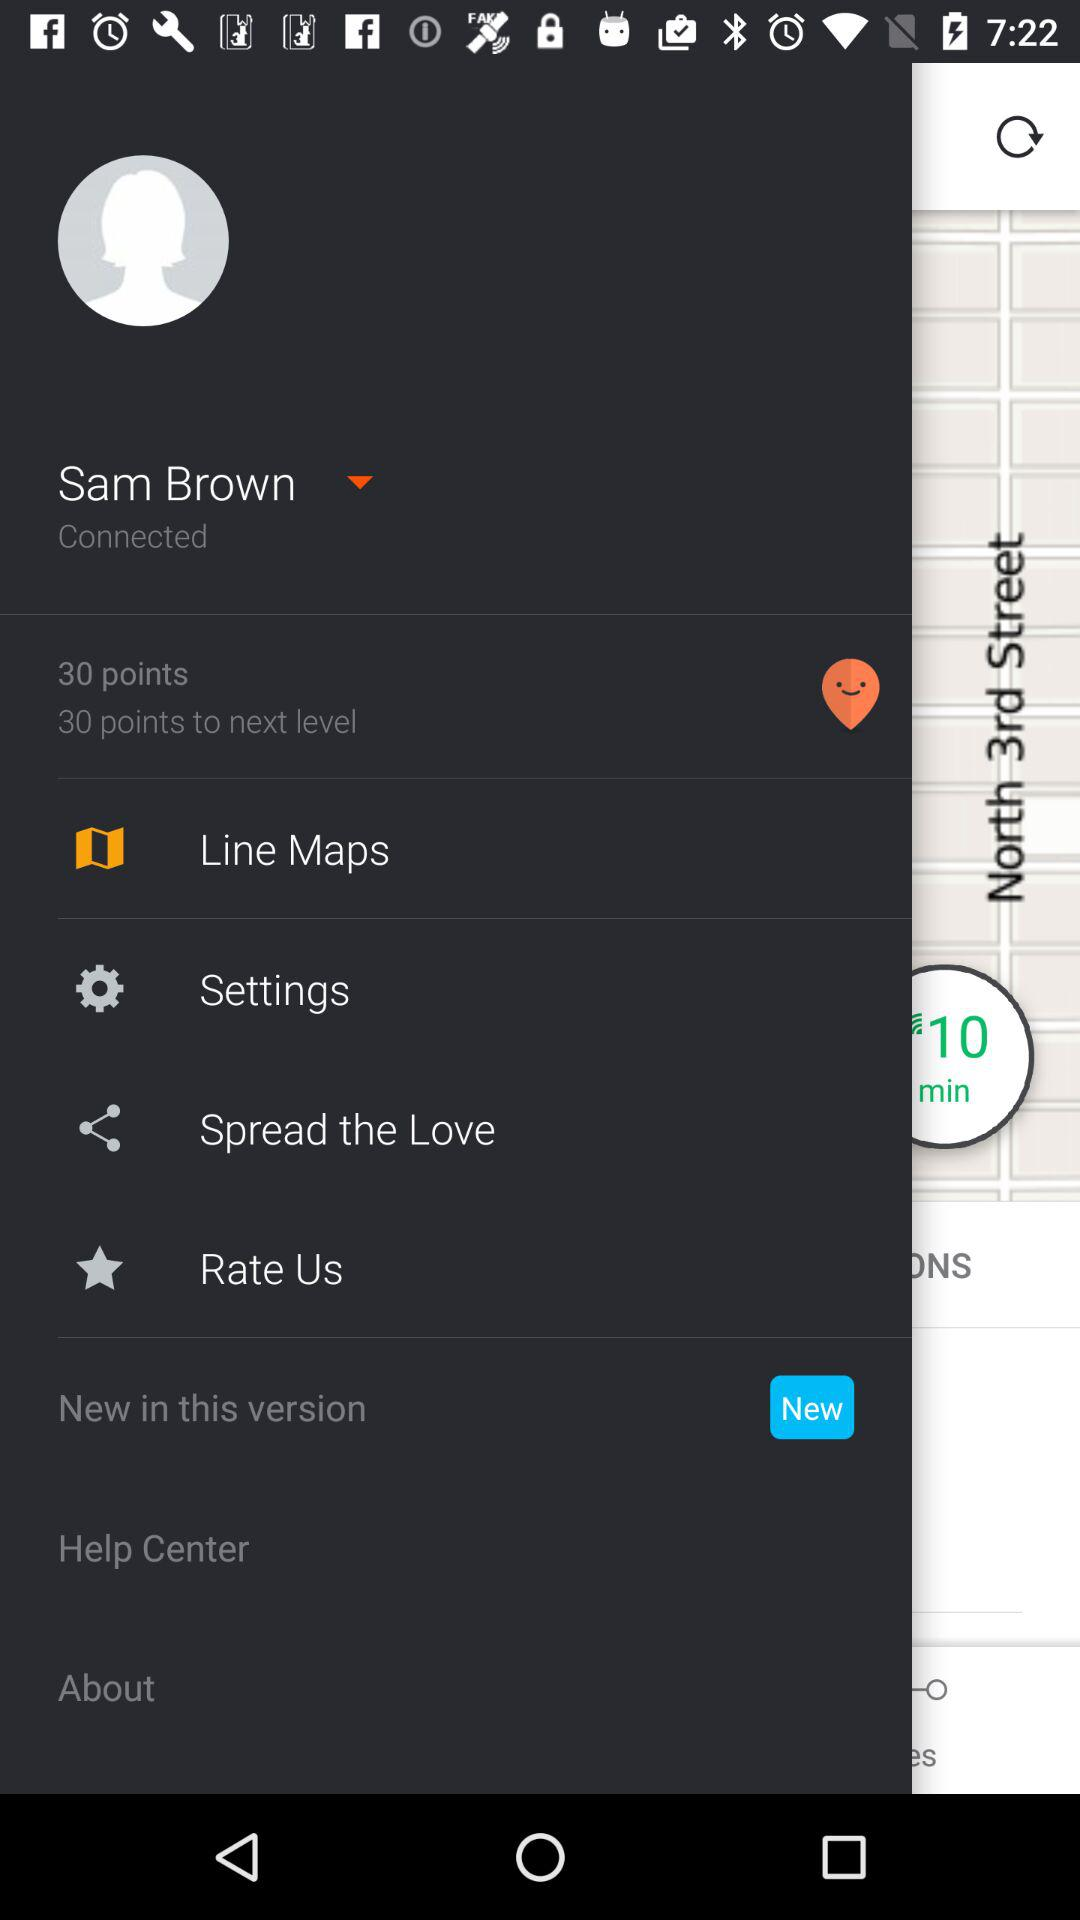What is the status of New in this version?
When the provided information is insufficient, respond with <no answer>. <no answer> 